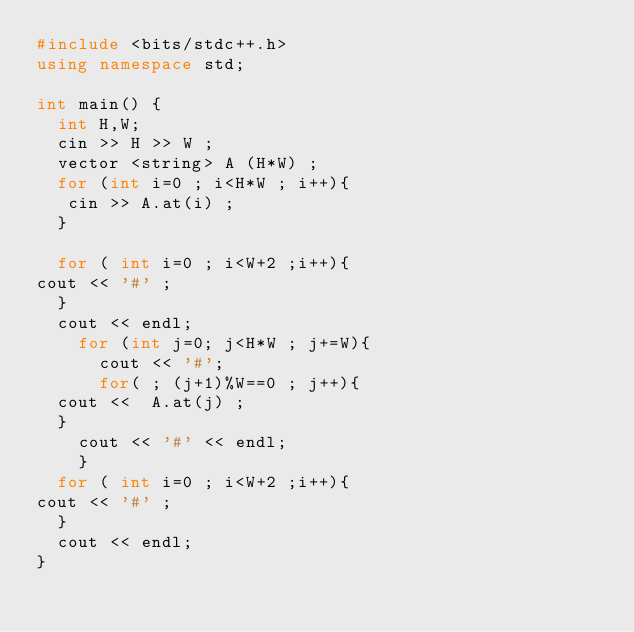<code> <loc_0><loc_0><loc_500><loc_500><_C++_>#include <bits/stdc++.h>
using namespace std;
 
int main() {
  int H,W;
  cin >> H >> W ;
  vector <string> A (H*W) ;
  for (int i=0 ; i<H*W ; i++){
   cin >> A.at(i) ;  
  }
 
  for ( int i=0 ; i<W+2 ;i++){
cout << '#' ;
  }
  cout << endl;
    for (int j=0; j<H*W ; j+=W){
      cout << '#';
      for( ; (j+1)%W==0 ; j++){
  cout <<  A.at(j) ;
  }
    cout << '#' << endl;
    }
  for ( int i=0 ; i<W+2 ;i++){
cout << '#' ;
  }
  cout << endl;
}</code> 